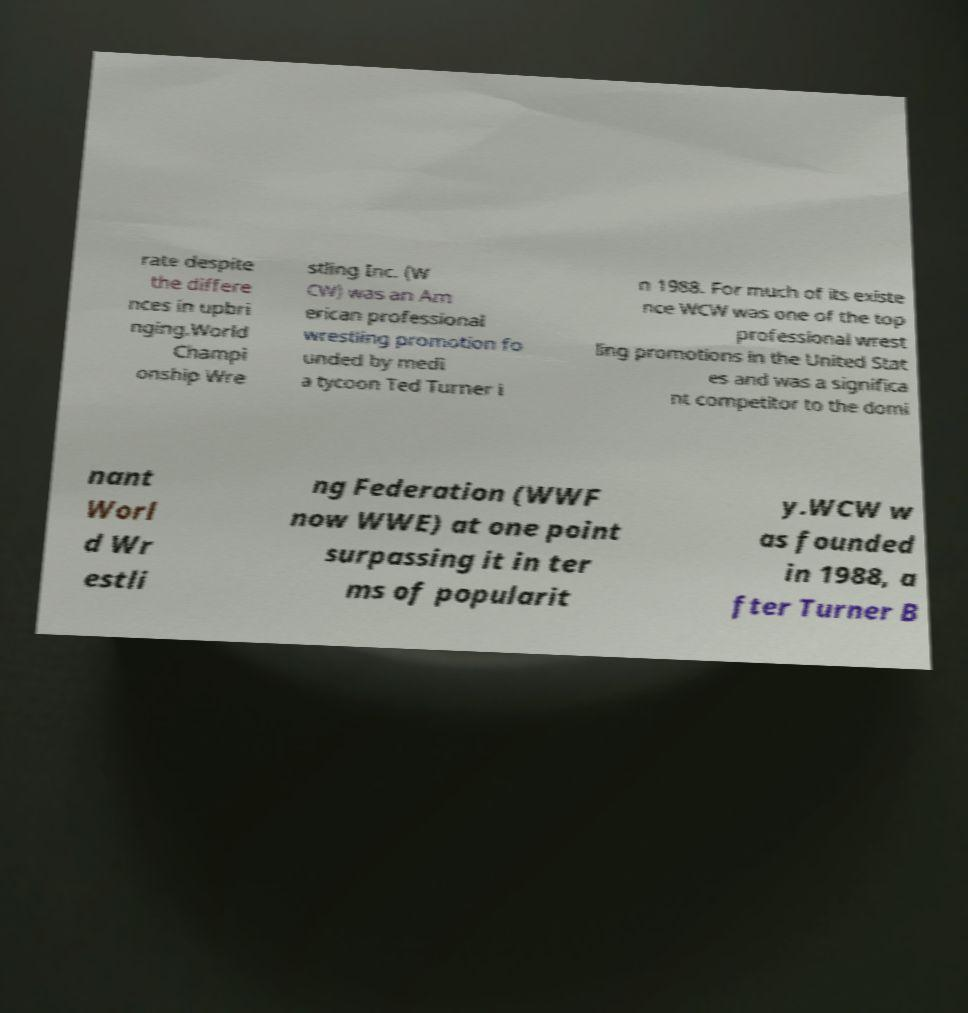For documentation purposes, I need the text within this image transcribed. Could you provide that? rate despite the differe nces in upbri nging.World Champi onship Wre stling Inc. (W CW) was an Am erican professional wrestling promotion fo unded by medi a tycoon Ted Turner i n 1988. For much of its existe nce WCW was one of the top professional wrest ling promotions in the United Stat es and was a significa nt competitor to the domi nant Worl d Wr estli ng Federation (WWF now WWE) at one point surpassing it in ter ms of popularit y.WCW w as founded in 1988, a fter Turner B 